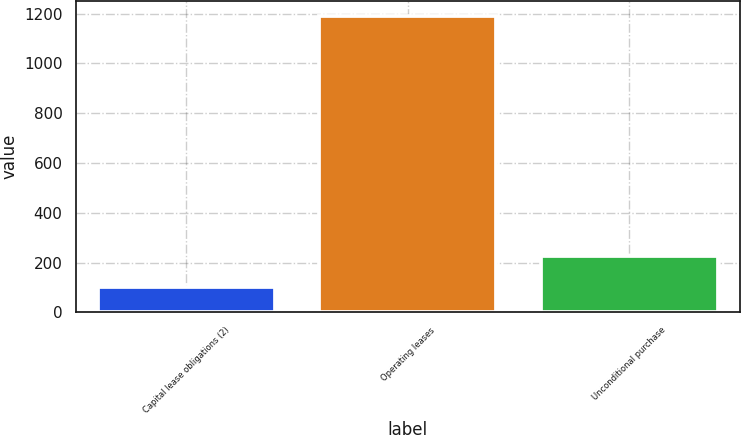Convert chart. <chart><loc_0><loc_0><loc_500><loc_500><bar_chart><fcel>Capital lease obligations (2)<fcel>Operating leases<fcel>Unconditional purchase<nl><fcel>102<fcel>1192<fcel>227<nl></chart> 